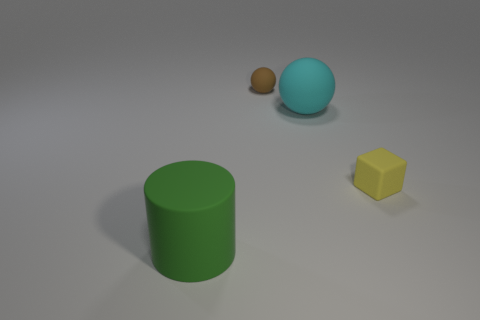What is the size of the other object that is the same shape as the brown thing?
Make the answer very short. Large. Are there any other things that are the same size as the brown sphere?
Provide a succinct answer. Yes. The small thing on the left side of the big thing behind the matte cylinder is made of what material?
Offer a very short reply. Rubber. Is the big green object the same shape as the large cyan object?
Offer a terse response. No. What number of rubber objects are on the left side of the brown ball and right of the large matte cylinder?
Make the answer very short. 0. Is the number of cylinders on the right side of the brown sphere the same as the number of cyan rubber things that are right of the large green matte object?
Keep it short and to the point. No. Do the thing on the left side of the brown rubber thing and the sphere in front of the tiny brown matte ball have the same size?
Give a very brief answer. Yes. What is the material of the object that is both in front of the large cyan rubber sphere and left of the large cyan rubber thing?
Offer a terse response. Rubber. Is the number of large green rubber objects less than the number of red matte cylinders?
Your answer should be compact. No. What size is the green cylinder that is left of the tiny thing that is behind the cyan sphere?
Give a very brief answer. Large. 